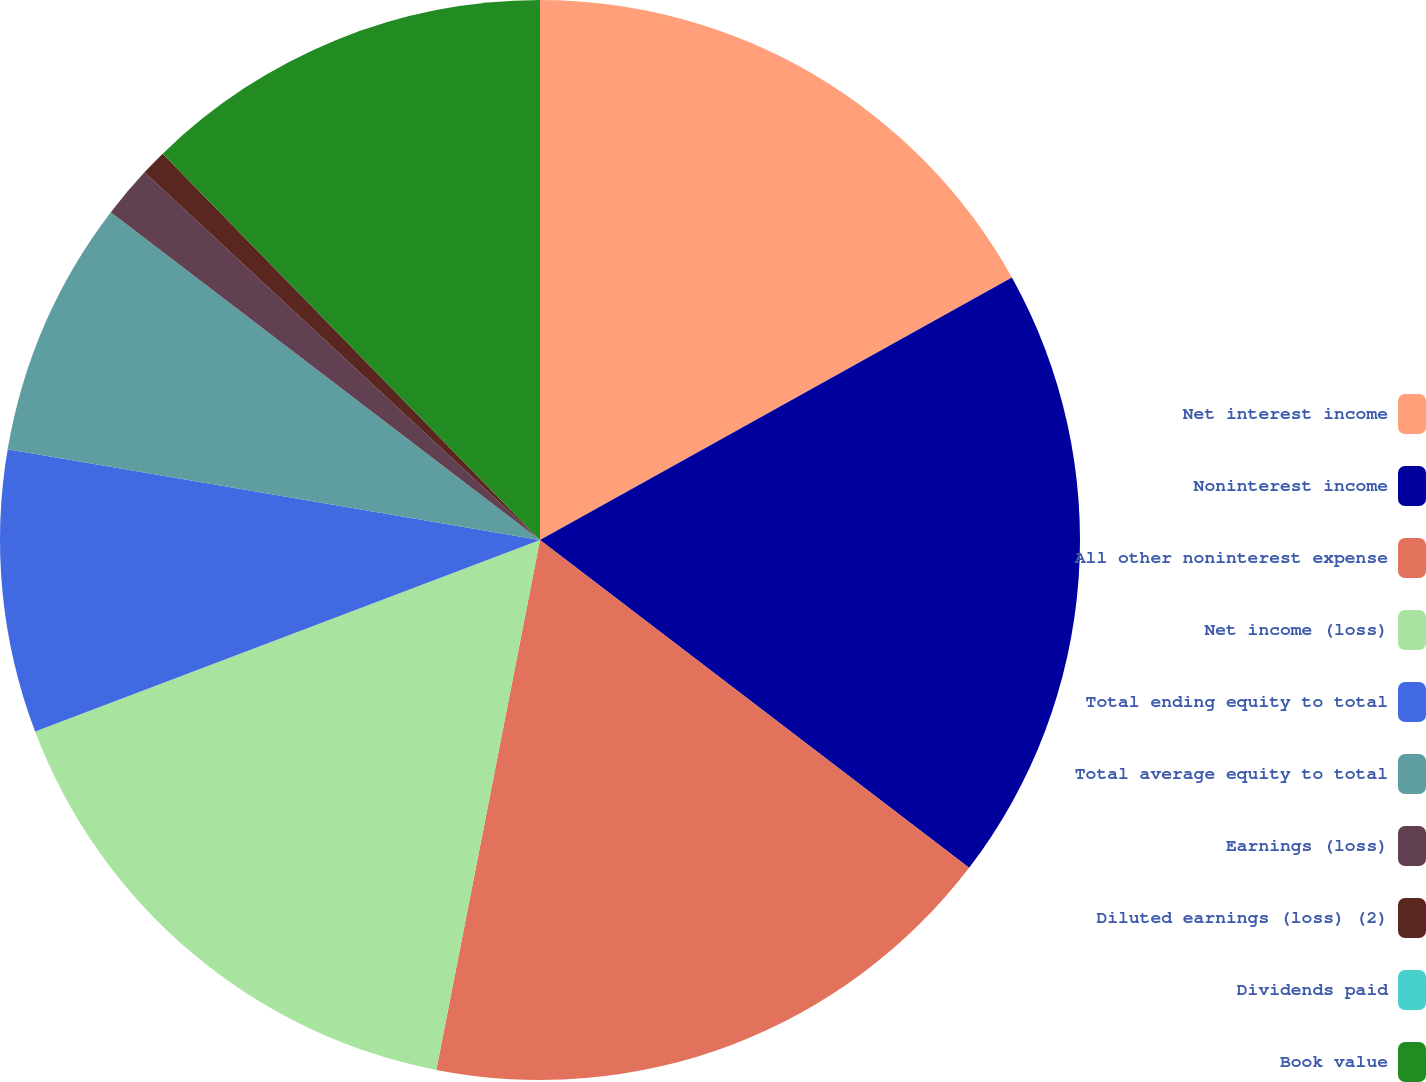Convert chart. <chart><loc_0><loc_0><loc_500><loc_500><pie_chart><fcel>Net interest income<fcel>Noninterest income<fcel>All other noninterest expense<fcel>Net income (loss)<fcel>Total ending equity to total<fcel>Total average equity to total<fcel>Earnings (loss)<fcel>Diluted earnings (loss) (2)<fcel>Dividends paid<fcel>Book value<nl><fcel>16.92%<fcel>18.46%<fcel>17.69%<fcel>16.15%<fcel>8.46%<fcel>7.69%<fcel>1.54%<fcel>0.77%<fcel>0.0%<fcel>12.31%<nl></chart> 